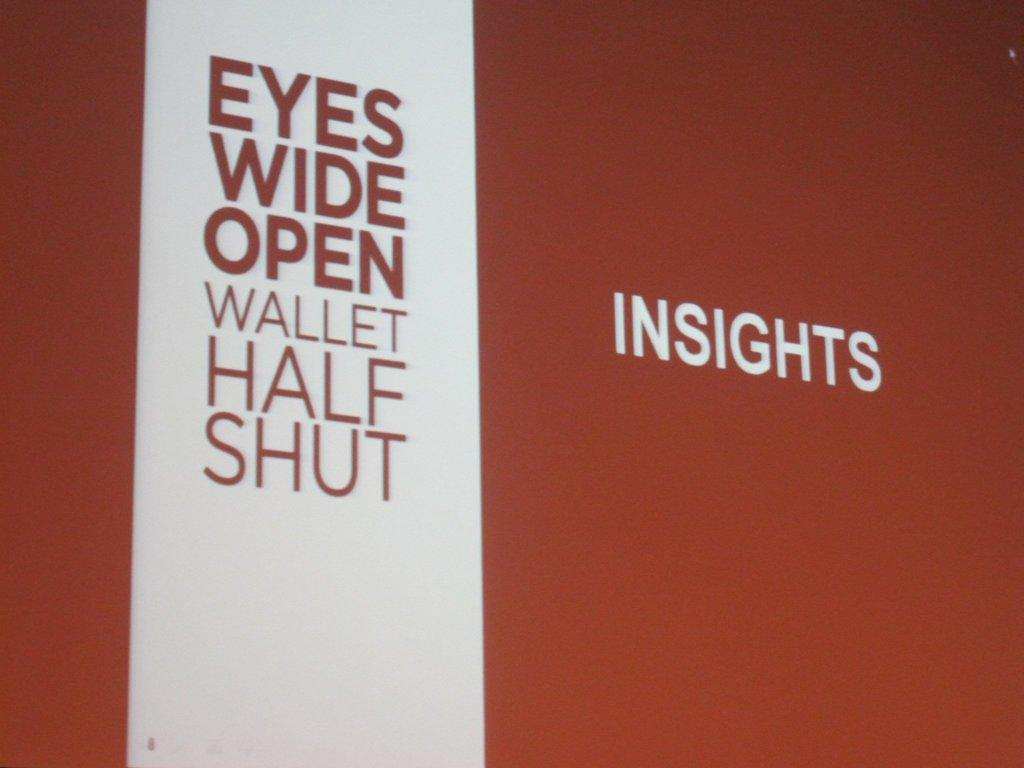What is the main subject of the image? The main subject of the image is texts written on a platform. Can you describe the platform in the image? Unfortunately, the provided facts do not give any information about the platform's appearance or characteristics. What type of texts are written on the platform? The provided facts do not specify the type of texts written on the platform. How does the mist affect the visibility of the river in the image? There is no mention of mist, river, or any other landscape elements in the provided facts. The image only contains texts written on a platform. 